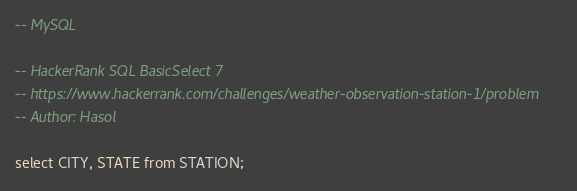Convert code to text. <code><loc_0><loc_0><loc_500><loc_500><_SQL_>-- MySQL

-- HackerRank SQL BasicSelect 7
-- https://www.hackerrank.com/challenges/weather-observation-station-1/problem
-- Author: Hasol

select CITY, STATE from STATION;
</code> 